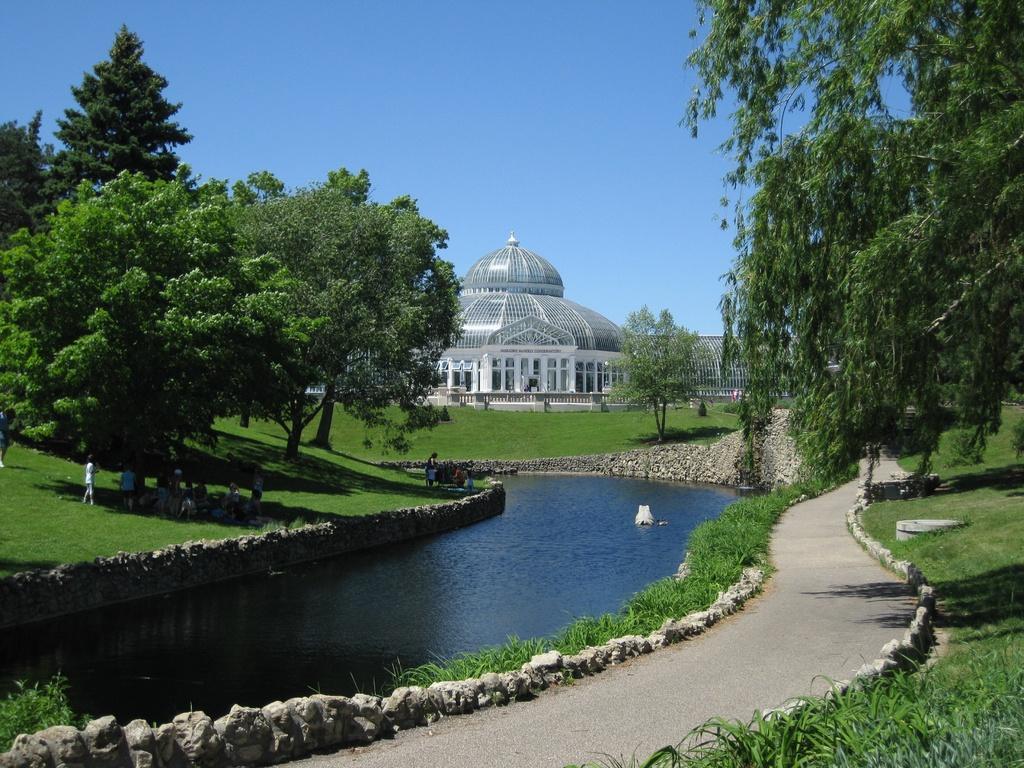How would you summarize this image in a sentence or two? In this image I can see the water. To the side of the water I can see the rocks and few people with different color dresses. And I can also see the trees to the side. In the back there is a building which is in ash color and the sky which is in blue color. 